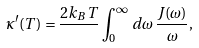Convert formula to latex. <formula><loc_0><loc_0><loc_500><loc_500>\kappa ^ { \prime } ( T ) = \frac { 2 k _ { B } T } { } \int _ { 0 } ^ { \infty } \, d \omega \, \frac { J ( \omega ) } { \omega } ,</formula> 